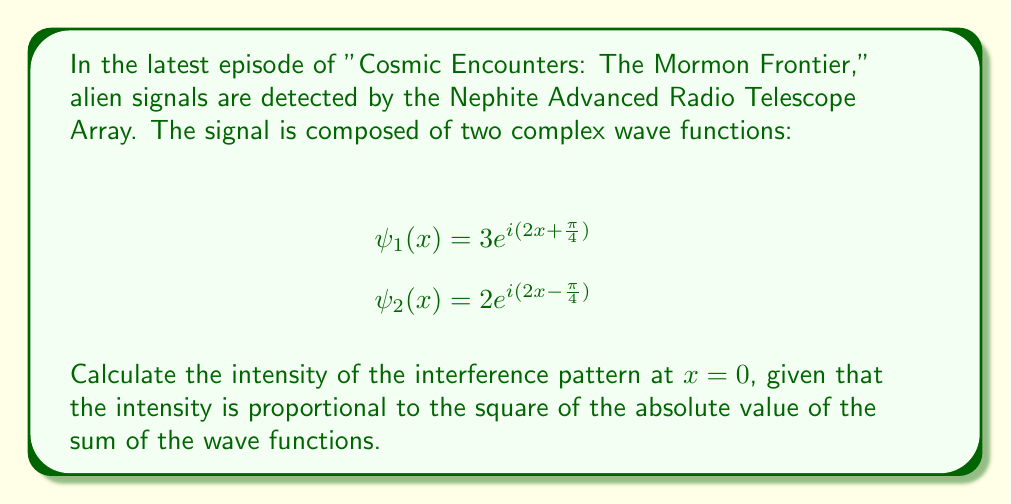Can you answer this question? To solve this problem, we'll follow these steps:

1) First, we need to add the two wave functions at $x = 0$:

   $$\psi(0) = \psi_1(0) + \psi_2(0)$$

2) Let's calculate $\psi_1(0)$:
   $$\psi_1(0) = 3e^{i(2(0) + \frac{\pi}{4})} = 3e^{i\frac{\pi}{4}}$$

3) Now, $\psi_2(0)$:
   $$\psi_2(0) = 2e^{i(2(0) - \frac{\pi}{4})} = 2e^{-i\frac{\pi}{4}}$$

4) Adding these:
   $$\psi(0) = 3e^{i\frac{\pi}{4}} + 2e^{-i\frac{\pi}{4}}$$

5) The intensity is proportional to the square of the absolute value of this sum:
   $$I \propto |\psi(0)|^2 = |3e^{i\frac{\pi}{4}} + 2e^{-i\frac{\pi}{4}}|^2$$

6) To calculate this, let's use Euler's formula: $e^{i\theta} = \cos\theta + i\sin\theta$

   $$3e^{i\frac{\pi}{4}} = 3(\frac{\sqrt{2}}{2} + i\frac{\sqrt{2}}{2})$$
   $$2e^{-i\frac{\pi}{4}} = 2(\frac{\sqrt{2}}{2} - i\frac{\sqrt{2}}{2})$$

7) Adding these:
   $$\psi(0) = (3+2)\frac{\sqrt{2}}{2} + i(3-2)\frac{\sqrt{2}}{2} = \frac{5\sqrt{2}}{2} + i\frac{\sqrt{2}}{2}$$

8) The absolute value squared is the sum of the squares of the real and imaginary parts:
   $$|\psi(0)|^2 = (\frac{5\sqrt{2}}{2})^2 + (\frac{\sqrt{2}}{2})^2 = \frac{50}{4} + \frac{1}{4} = \frac{51}{4} = 12.75$$

Therefore, the intensity of the interference pattern at $x = 0$ is proportional to 12.75.
Answer: The intensity of the interference pattern at $x = 0$ is proportional to 12.75. 